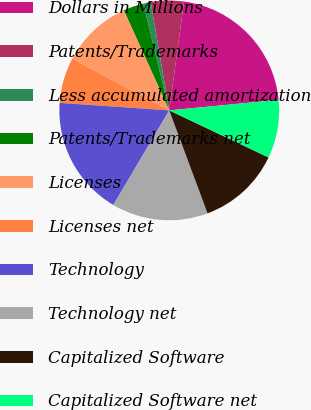<chart> <loc_0><loc_0><loc_500><loc_500><pie_chart><fcel>Dollars in Millions<fcel>Patents/Trademarks<fcel>Less accumulated amortization<fcel>Patents/Trademarks net<fcel>Licenses<fcel>Licenses net<fcel>Technology<fcel>Technology net<fcel>Capitalized Software<fcel>Capitalized Software net<nl><fcel>21.33%<fcel>4.84%<fcel>1.11%<fcel>2.98%<fcel>10.43%<fcel>6.7%<fcel>17.6%<fcel>14.16%<fcel>12.29%<fcel>8.57%<nl></chart> 